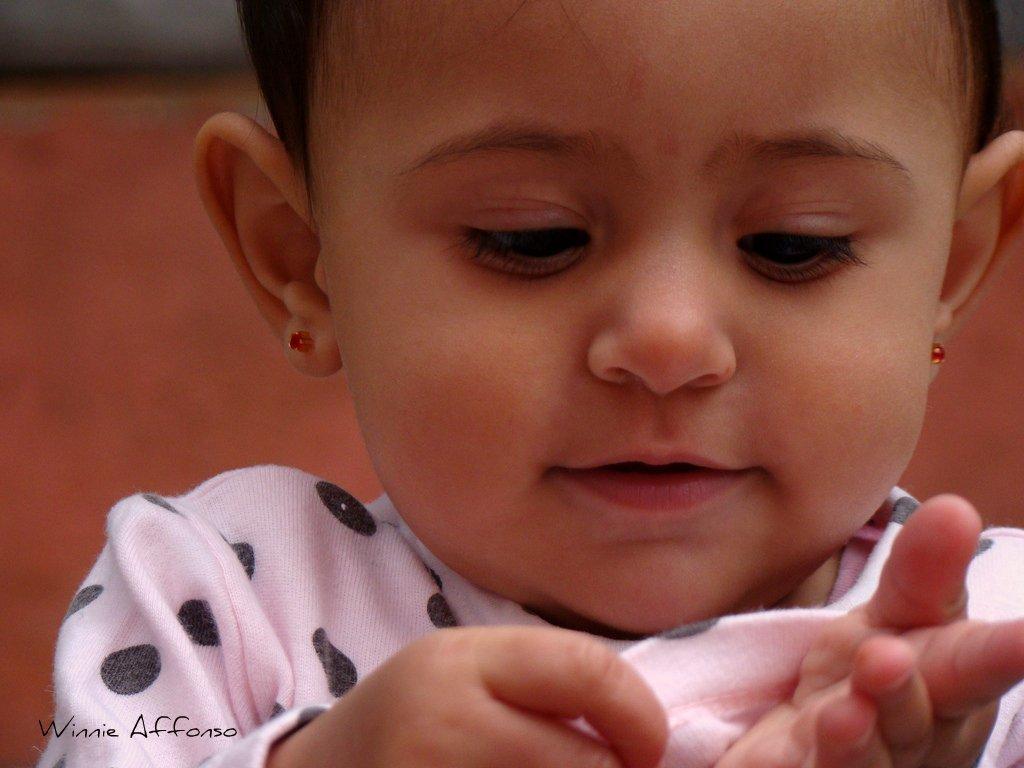Please provide a concise description of this image. In this picture we can see a kid and there is a blur background. 